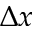Convert formula to latex. <formula><loc_0><loc_0><loc_500><loc_500>\Delta x</formula> 